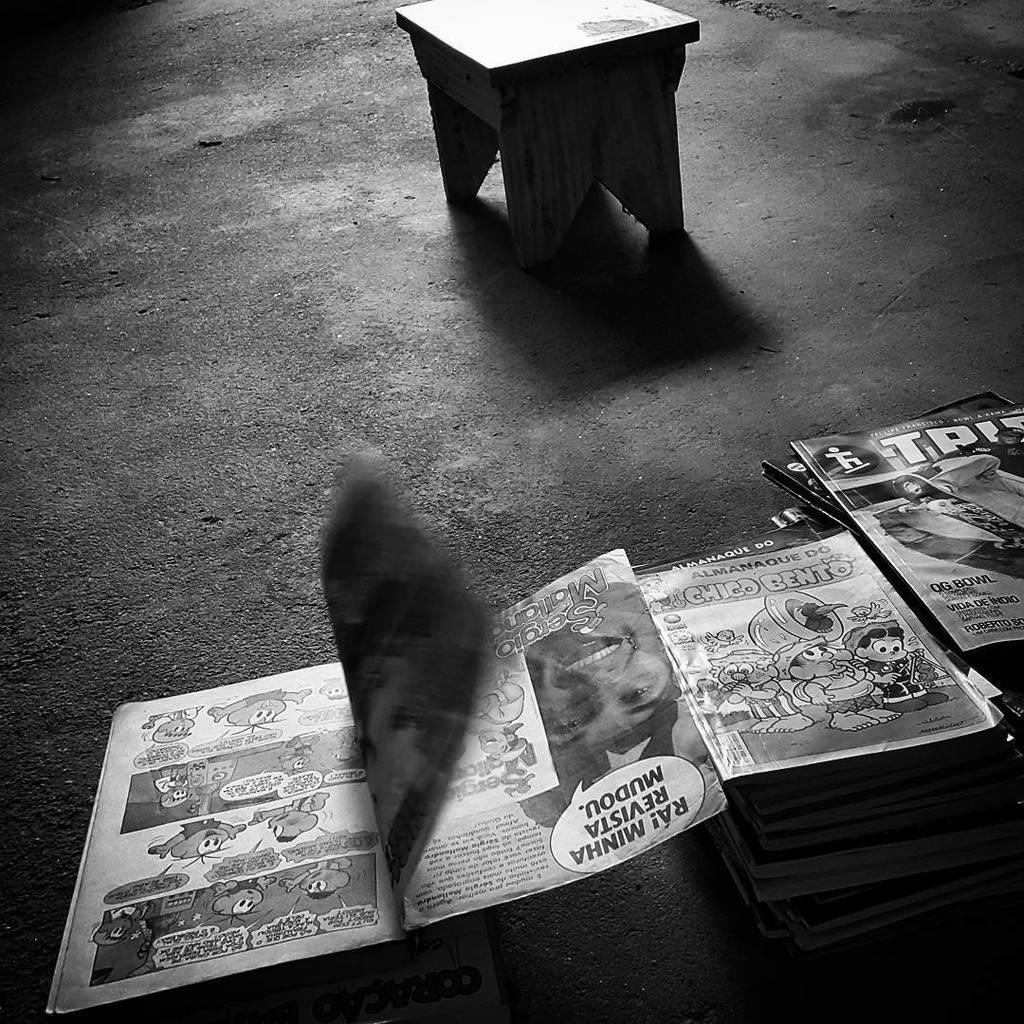Could you give a brief overview of what you see in this image? In the down side there are books and at the top it is a stool. 